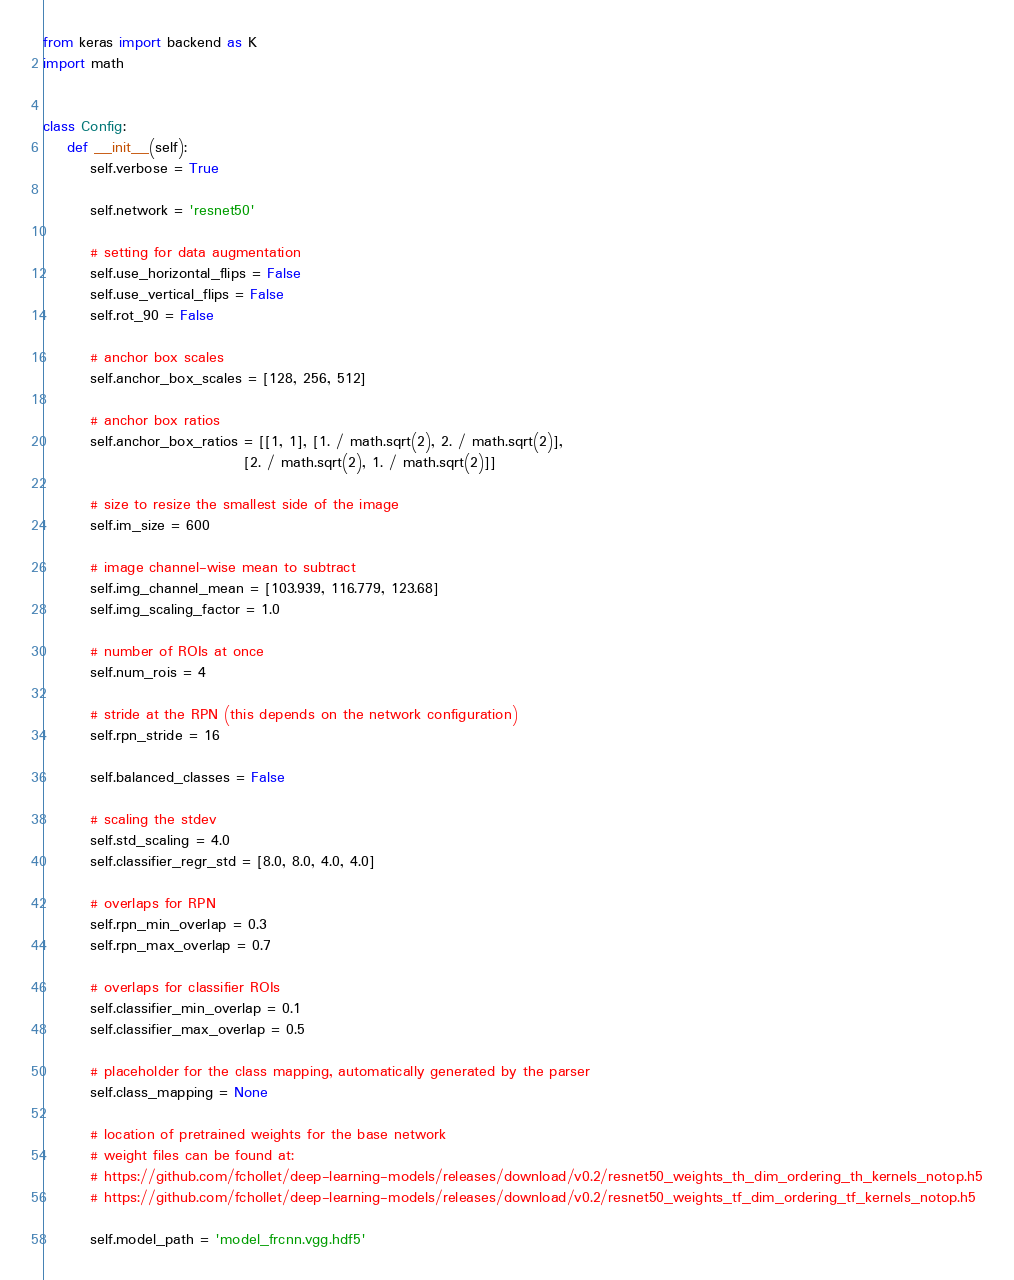Convert code to text. <code><loc_0><loc_0><loc_500><loc_500><_Python_>from keras import backend as K
import math


class Config:
    def __init__(self):
        self.verbose = True

        self.network = 'resnet50'

        # setting for data augmentation
        self.use_horizontal_flips = False
        self.use_vertical_flips = False
        self.rot_90 = False

        # anchor box scales
        self.anchor_box_scales = [128, 256, 512]

        # anchor box ratios
        self.anchor_box_ratios = [[1, 1], [1. / math.sqrt(2), 2. / math.sqrt(2)],
                                  [2. / math.sqrt(2), 1. / math.sqrt(2)]]

        # size to resize the smallest side of the image
        self.im_size = 600

        # image channel-wise mean to subtract
        self.img_channel_mean = [103.939, 116.779, 123.68]
        self.img_scaling_factor = 1.0

        # number of ROIs at once
        self.num_rois = 4

        # stride at the RPN (this depends on the network configuration)
        self.rpn_stride = 16

        self.balanced_classes = False

        # scaling the stdev
        self.std_scaling = 4.0
        self.classifier_regr_std = [8.0, 8.0, 4.0, 4.0]

        # overlaps for RPN
        self.rpn_min_overlap = 0.3
        self.rpn_max_overlap = 0.7

        # overlaps for classifier ROIs
        self.classifier_min_overlap = 0.1
        self.classifier_max_overlap = 0.5

        # placeholder for the class mapping, automatically generated by the parser
        self.class_mapping = None

        # location of pretrained weights for the base network
        # weight files can be found at:
        # https://github.com/fchollet/deep-learning-models/releases/download/v0.2/resnet50_weights_th_dim_ordering_th_kernels_notop.h5
        # https://github.com/fchollet/deep-learning-models/releases/download/v0.2/resnet50_weights_tf_dim_ordering_tf_kernels_notop.h5

        self.model_path = 'model_frcnn.vgg.hdf5'
</code> 